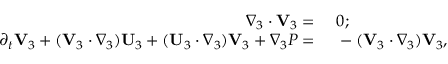Convert formula to latex. <formula><loc_0><loc_0><loc_500><loc_500>\begin{array} { r l } { \nabla _ { 3 } \cdot V _ { 3 } = } & 0 ; } \\ { \partial _ { t } V _ { 3 } + ( V _ { 3 } \cdot \nabla _ { 3 } ) U _ { 3 } + ( U _ { 3 } \cdot \nabla _ { 3 } ) V _ { 3 } + \nabla _ { 3 } P = } & - ( V _ { 3 } \cdot \nabla _ { 3 } ) V _ { 3 } , } \end{array}</formula> 